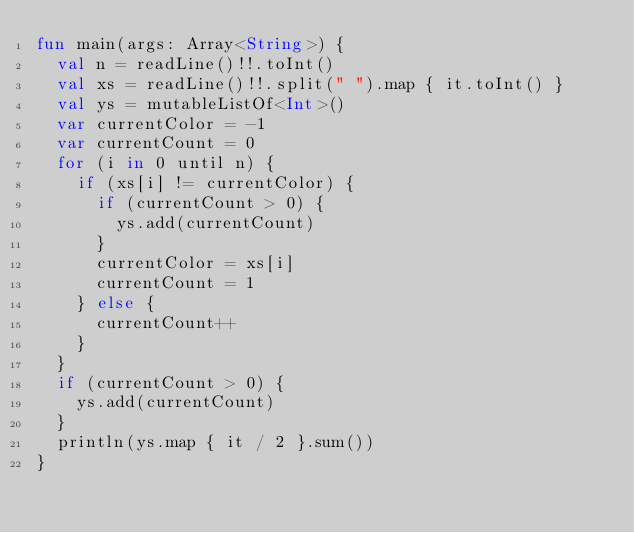Convert code to text. <code><loc_0><loc_0><loc_500><loc_500><_Kotlin_>fun main(args: Array<String>) {
  val n = readLine()!!.toInt()
  val xs = readLine()!!.split(" ").map { it.toInt() }
  val ys = mutableListOf<Int>()
  var currentColor = -1
  var currentCount = 0
  for (i in 0 until n) {
    if (xs[i] != currentColor) {
      if (currentCount > 0) {
        ys.add(currentCount)
      }
      currentColor = xs[i]
      currentCount = 1
    } else {
      currentCount++
    }
  }
  if (currentCount > 0) {
    ys.add(currentCount)
  }
  println(ys.map { it / 2 }.sum())
}</code> 